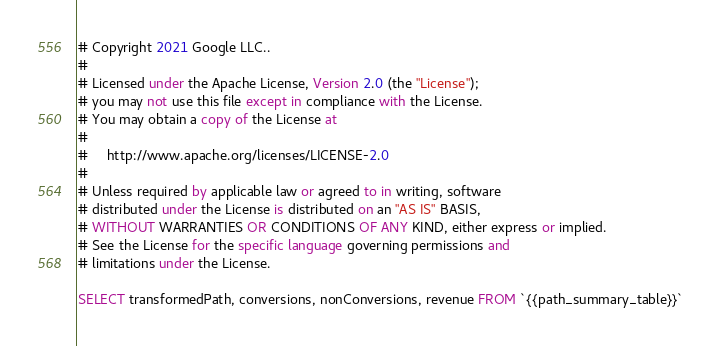<code> <loc_0><loc_0><loc_500><loc_500><_SQL_># Copyright 2021 Google LLC..
#
# Licensed under the Apache License, Version 2.0 (the "License");
# you may not use this file except in compliance with the License.
# You may obtain a copy of the License at
#
#     http://www.apache.org/licenses/LICENSE-2.0
#
# Unless required by applicable law or agreed to in writing, software
# distributed under the License is distributed on an "AS IS" BASIS,
# WITHOUT WARRANTIES OR CONDITIONS OF ANY KIND, either express or implied.
# See the License for the specific language governing permissions and
# limitations under the License.

SELECT transformedPath, conversions, nonConversions, revenue FROM `{{path_summary_table}}`
</code> 